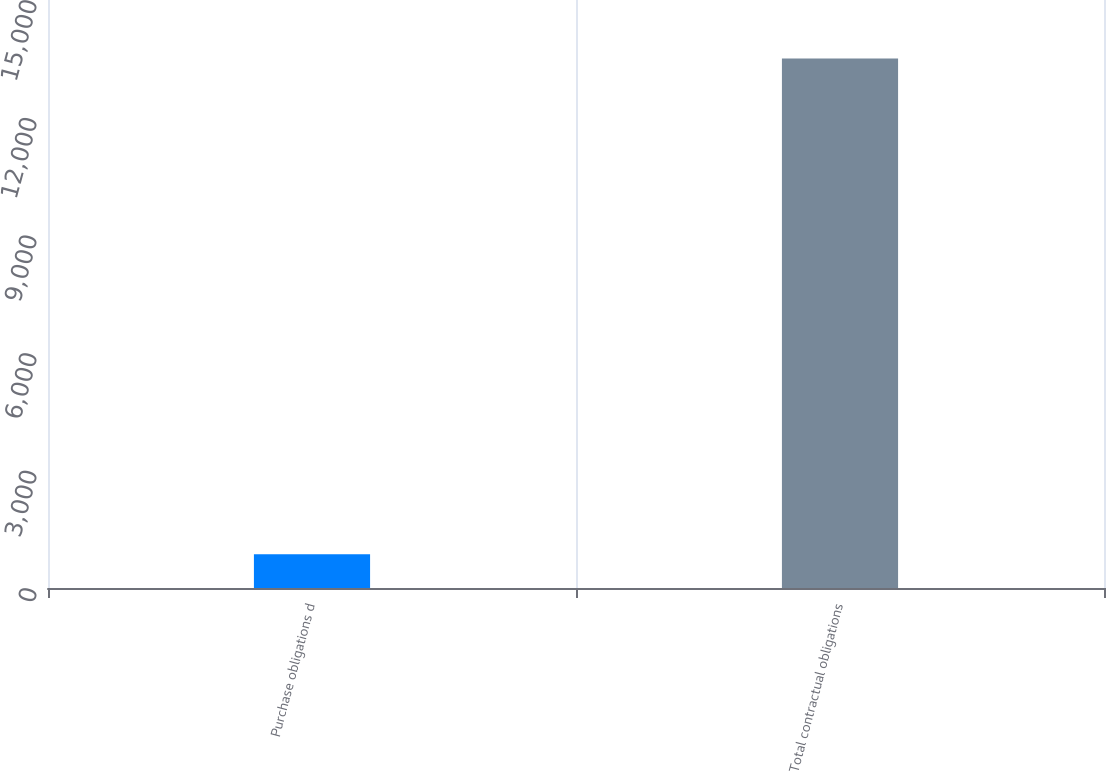Convert chart to OTSL. <chart><loc_0><loc_0><loc_500><loc_500><bar_chart><fcel>Purchase obligations d<fcel>Total contractual obligations<nl><fcel>858<fcel>13508<nl></chart> 